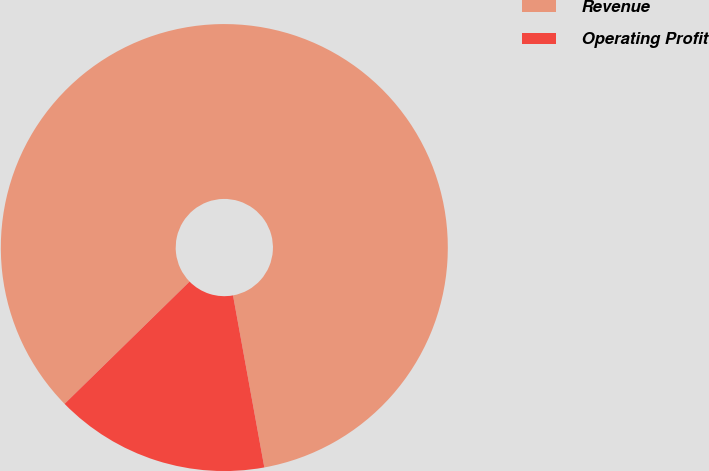Convert chart to OTSL. <chart><loc_0><loc_0><loc_500><loc_500><pie_chart><fcel>Revenue<fcel>Operating Profit<nl><fcel>84.46%<fcel>15.54%<nl></chart> 